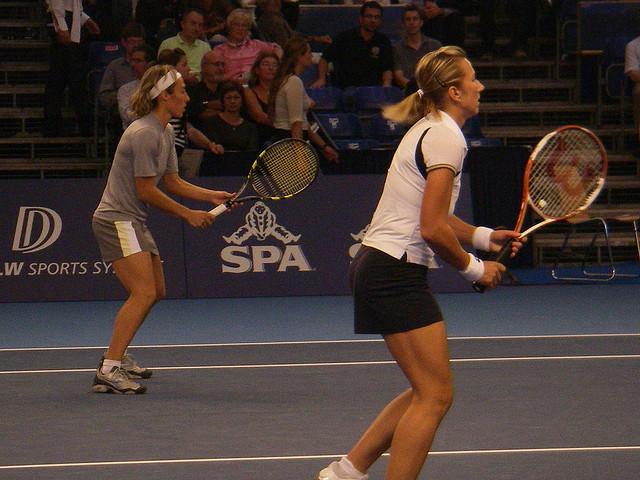What color is the woman skirt?
Short answer required. Black. Are these two women opponents?
Be succinct. No. What color are her shoes?
Give a very brief answer. White. What are these people holding?
Answer briefly. Tennis rackets. 